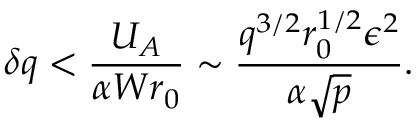Convert formula to latex. <formula><loc_0><loc_0><loc_500><loc_500>\delta q < { \frac { U _ { A } } { \alpha W r _ { 0 } } } \sim { \frac { q ^ { 3 / 2 } r _ { 0 } ^ { 1 / 2 } \epsilon ^ { 2 } } { \alpha \sqrt { p } } } .</formula> 